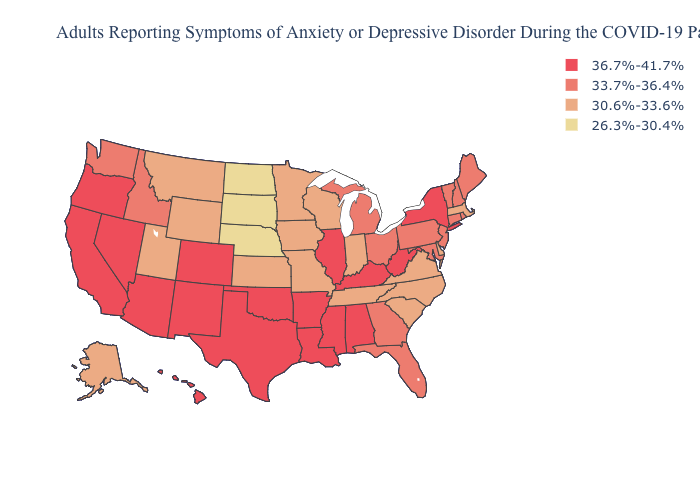What is the highest value in states that border Arizona?
Keep it brief. 36.7%-41.7%. Does New York have the same value as South Dakota?
Short answer required. No. Name the states that have a value in the range 36.7%-41.7%?
Write a very short answer. Alabama, Arizona, Arkansas, California, Colorado, Hawaii, Illinois, Kentucky, Louisiana, Mississippi, Nevada, New Mexico, New York, Oklahoma, Oregon, Texas, West Virginia. What is the value of Maine?
Keep it brief. 33.7%-36.4%. Name the states that have a value in the range 30.6%-33.6%?
Concise answer only. Alaska, Delaware, Indiana, Iowa, Kansas, Massachusetts, Minnesota, Missouri, Montana, North Carolina, South Carolina, Tennessee, Utah, Virginia, Wisconsin, Wyoming. Is the legend a continuous bar?
Quick response, please. No. Name the states that have a value in the range 36.7%-41.7%?
Write a very short answer. Alabama, Arizona, Arkansas, California, Colorado, Hawaii, Illinois, Kentucky, Louisiana, Mississippi, Nevada, New Mexico, New York, Oklahoma, Oregon, Texas, West Virginia. What is the lowest value in the MidWest?
Write a very short answer. 26.3%-30.4%. Does the map have missing data?
Write a very short answer. No. Name the states that have a value in the range 36.7%-41.7%?
Keep it brief. Alabama, Arizona, Arkansas, California, Colorado, Hawaii, Illinois, Kentucky, Louisiana, Mississippi, Nevada, New Mexico, New York, Oklahoma, Oregon, Texas, West Virginia. Name the states that have a value in the range 36.7%-41.7%?
Short answer required. Alabama, Arizona, Arkansas, California, Colorado, Hawaii, Illinois, Kentucky, Louisiana, Mississippi, Nevada, New Mexico, New York, Oklahoma, Oregon, Texas, West Virginia. Does Minnesota have a lower value than South Dakota?
Write a very short answer. No. What is the value of Nevada?
Answer briefly. 36.7%-41.7%. What is the value of Virginia?
Give a very brief answer. 30.6%-33.6%. What is the value of Delaware?
Answer briefly. 30.6%-33.6%. 